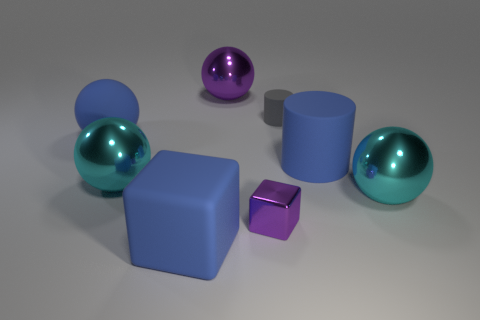Subtract all blue spheres. How many spheres are left? 3 Subtract all blue balls. How many balls are left? 3 Add 1 big balls. How many objects exist? 9 Subtract 2 cubes. How many cubes are left? 0 Subtract all brown cylinders. Subtract all cyan cubes. How many cylinders are left? 2 Subtract all green cubes. How many purple balls are left? 1 Subtract all small yellow things. Subtract all cyan metal objects. How many objects are left? 6 Add 1 purple balls. How many purple balls are left? 2 Add 7 small blue metallic balls. How many small blue metallic balls exist? 7 Subtract 0 green spheres. How many objects are left? 8 